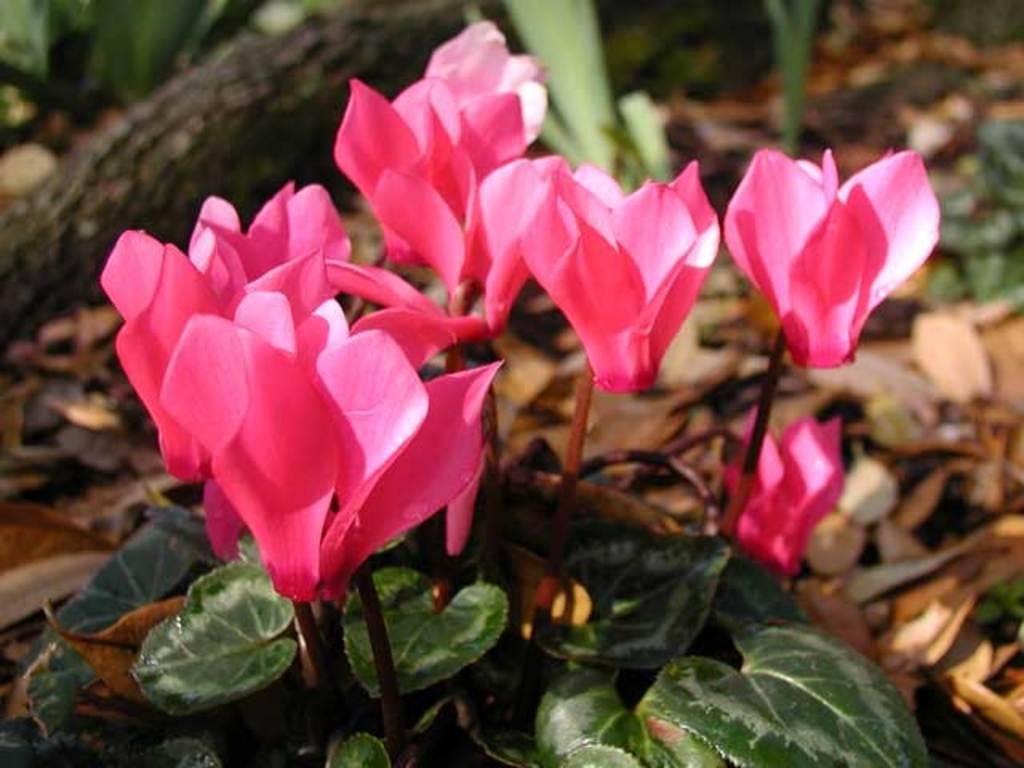What type of plants can be seen in the image? There are flowers in the image. What color are the flowers? The flowers are pink in color. What else can be seen in the image besides the flowers? There are leaves in the image. What color are the leaves? The leaves are green in color. What type of cart is visible in the image? There is no cart present in the image; it features flowers and leaves. How many suns can be seen in the image? There is no sun present in the image; it only features flowers and leaves. 